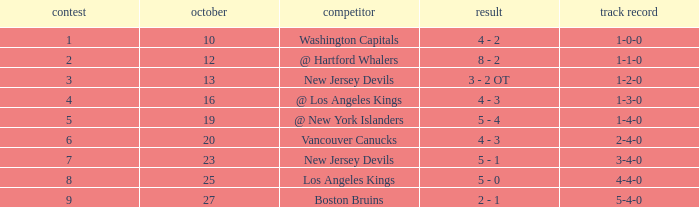Which game has the highest score in October with 9? 27.0. 